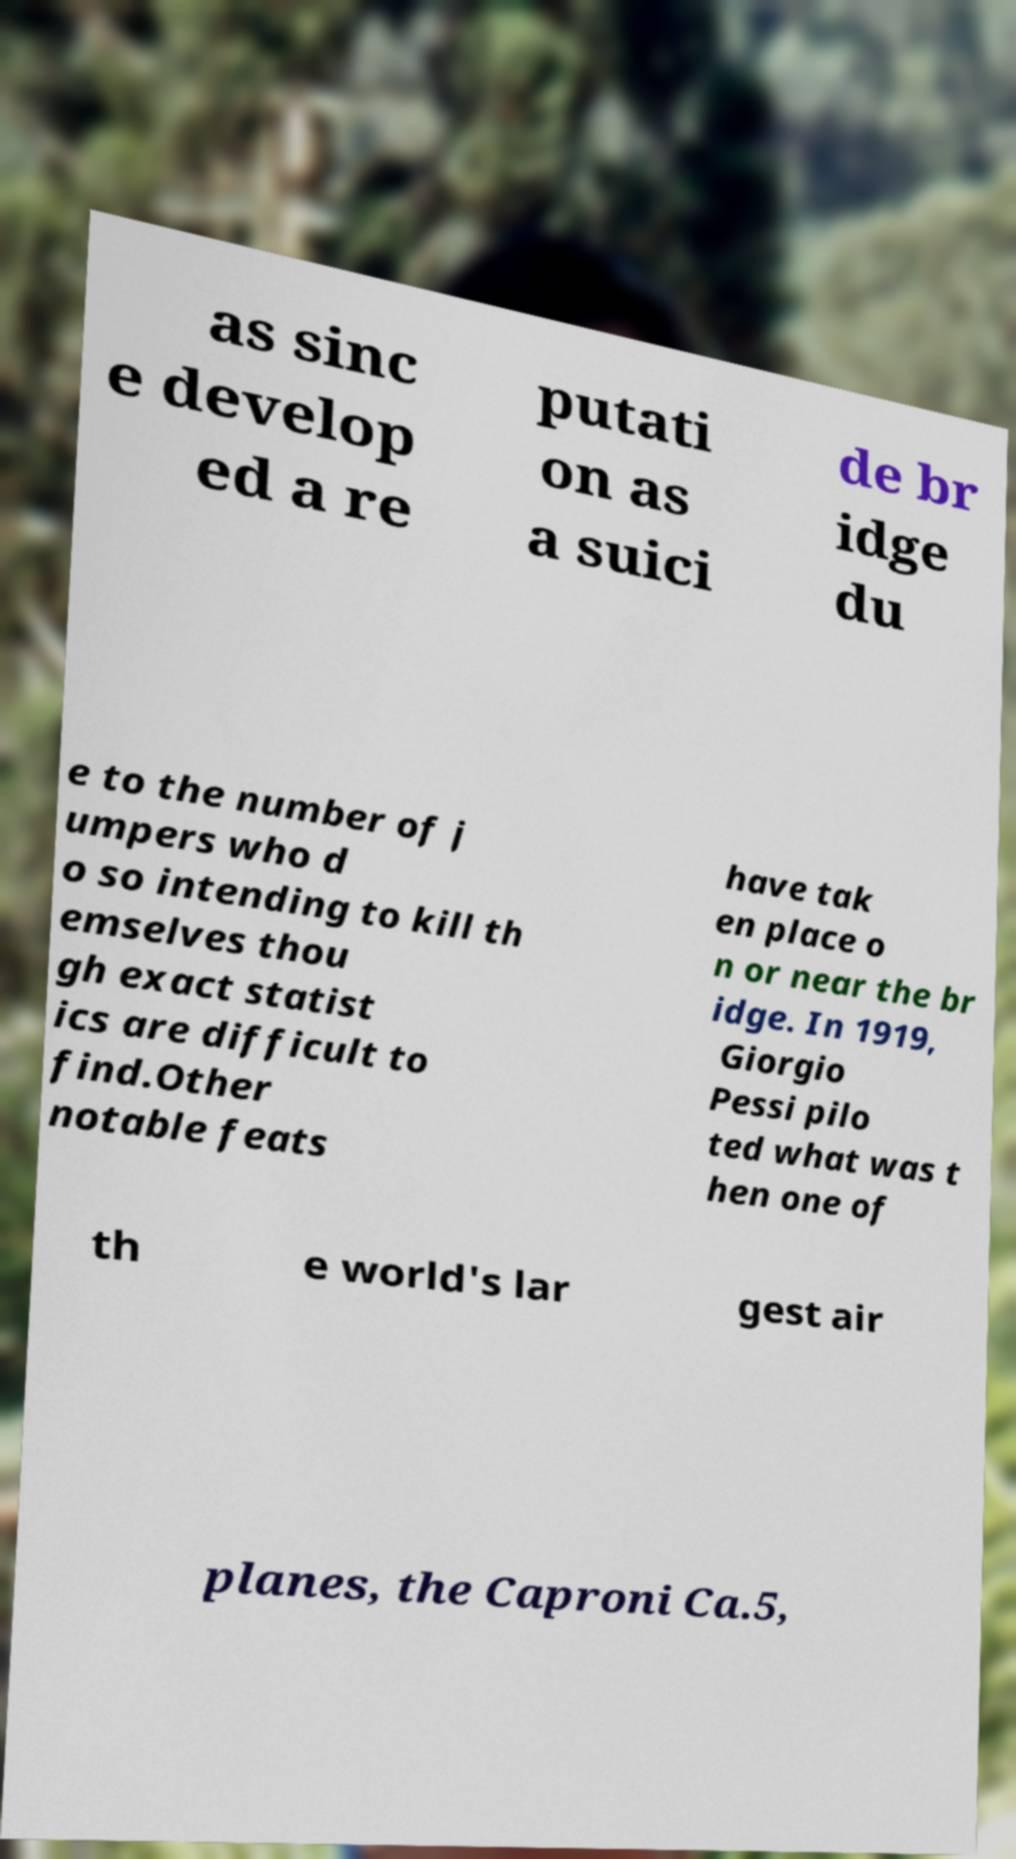I need the written content from this picture converted into text. Can you do that? as sinc e develop ed a re putati on as a suici de br idge du e to the number of j umpers who d o so intending to kill th emselves thou gh exact statist ics are difficult to find.Other notable feats have tak en place o n or near the br idge. In 1919, Giorgio Pessi pilo ted what was t hen one of th e world's lar gest air planes, the Caproni Ca.5, 